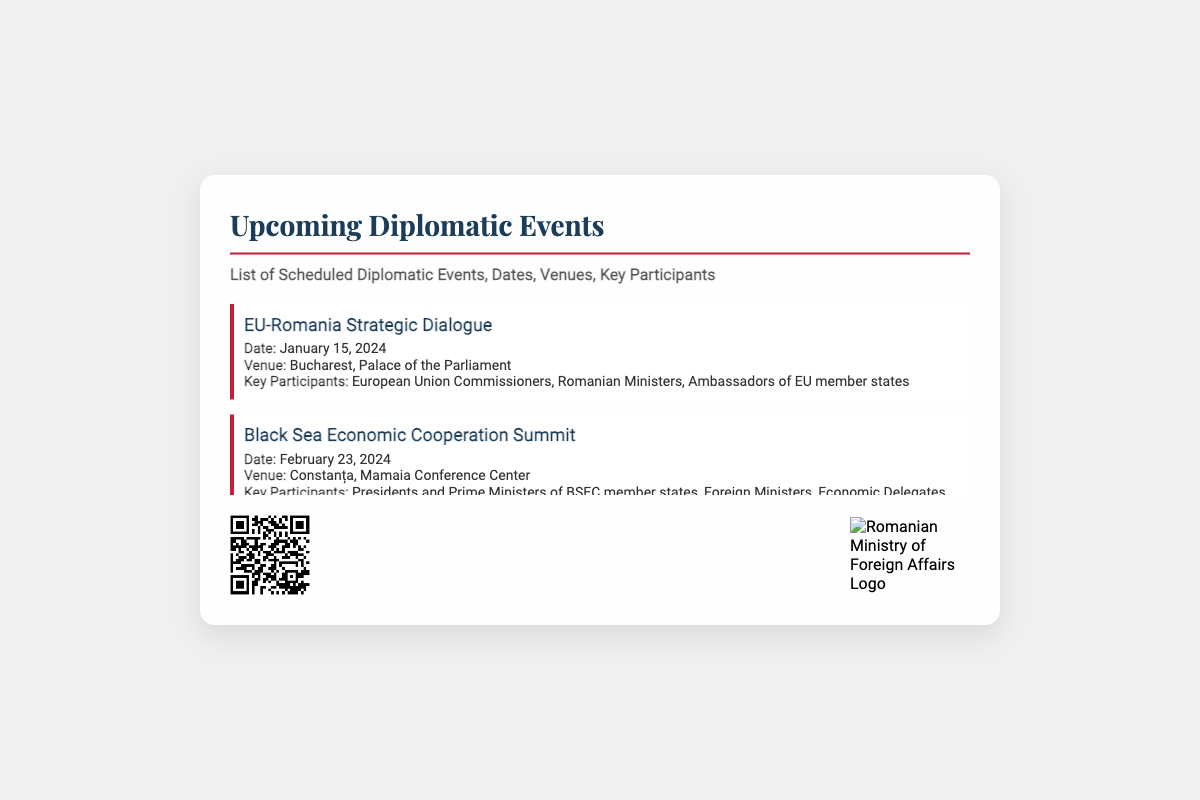what is the title of the document? The title of the document is stated at the top of the card.
Answer: Upcoming Diplomatic Events who is the key participant in the NATO Partnership Symposium? The document specifies key participants for each event, including the NATO Partnership Symposium.
Answer: NATO Secretary General when is the Black Sea Economic Cooperation Summit scheduled? The date for the Black Sea Economic Cooperation Summit is explicitly mentioned in the event details.
Answer: February 23, 2024 where will the Romania-USA Strategic Partnership Forum take place? The venue for the Romania-USA Strategic Partnership Forum is provided in the event details.
Answer: Bucharest, National Arena Conference Hall how many events are listed in the document? The number of events can be counted from the list provided in the document.
Answer: Five what type of event is scheduled on May 5, 2024? The specific type or focus of the event on that date is mentioned in the event details.
Answer: Environmental Conference which venue is associated with the EU-Romania Strategic Dialogue? The venue is clearly stated in the event details for the EU-Romania Strategic Dialogue.
Answer: Bucharest, Palace of the Parliament what is the purpose of the QR Code included in the document? The purpose of the QR Code is usually to provide additional information or access to more details.
Answer: Event Details who organized the upcoming diplomatic events? The organization responsible for the events is indicated by the logo at the bottom of the card.
Answer: Romanian Ministry of Foreign Affairs 